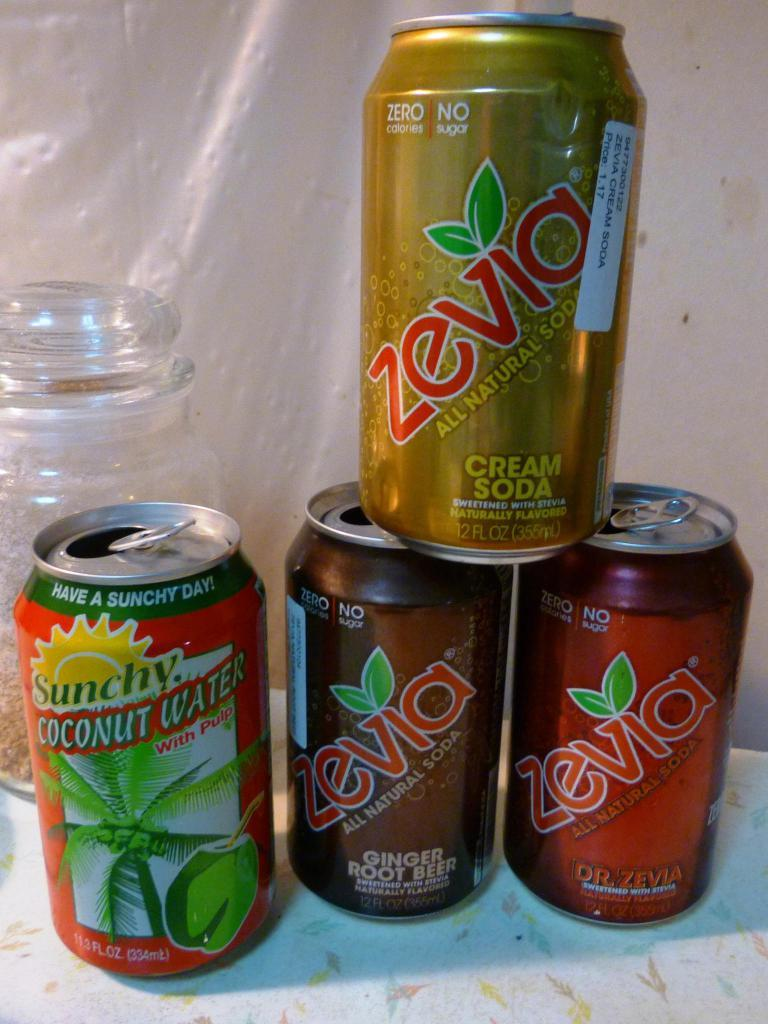<image>
Summarize the visual content of the image. A stack of soda cans of various flavors including Cream soda, coconut water, and ginger root beer. 